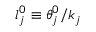<formula> <loc_0><loc_0><loc_500><loc_500>l _ { j } ^ { 0 } \equiv \theta _ { j } ^ { 0 } / k _ { j }</formula> 